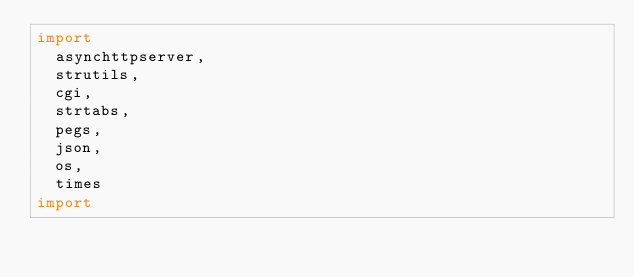Convert code to text. <code><loc_0><loc_0><loc_500><loc_500><_Nim_>import
  asynchttpserver,
  strutils,
  cgi,
  strtabs,
  pegs,
  json,
  os,
  times
import</code> 